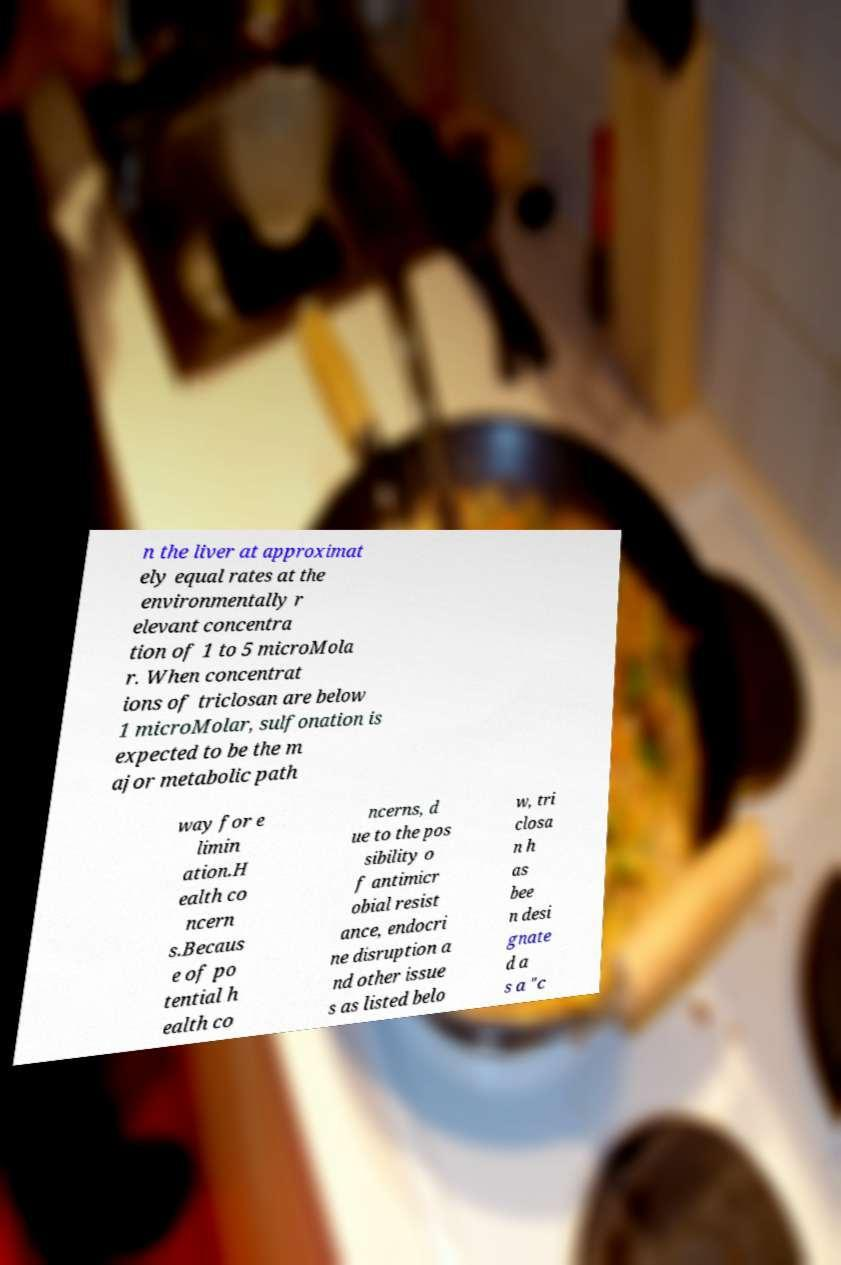For documentation purposes, I need the text within this image transcribed. Could you provide that? n the liver at approximat ely equal rates at the environmentally r elevant concentra tion of 1 to 5 microMola r. When concentrat ions of triclosan are below 1 microMolar, sulfonation is expected to be the m ajor metabolic path way for e limin ation.H ealth co ncern s.Becaus e of po tential h ealth co ncerns, d ue to the pos sibility o f antimicr obial resist ance, endocri ne disruption a nd other issue s as listed belo w, tri closa n h as bee n desi gnate d a s a "c 